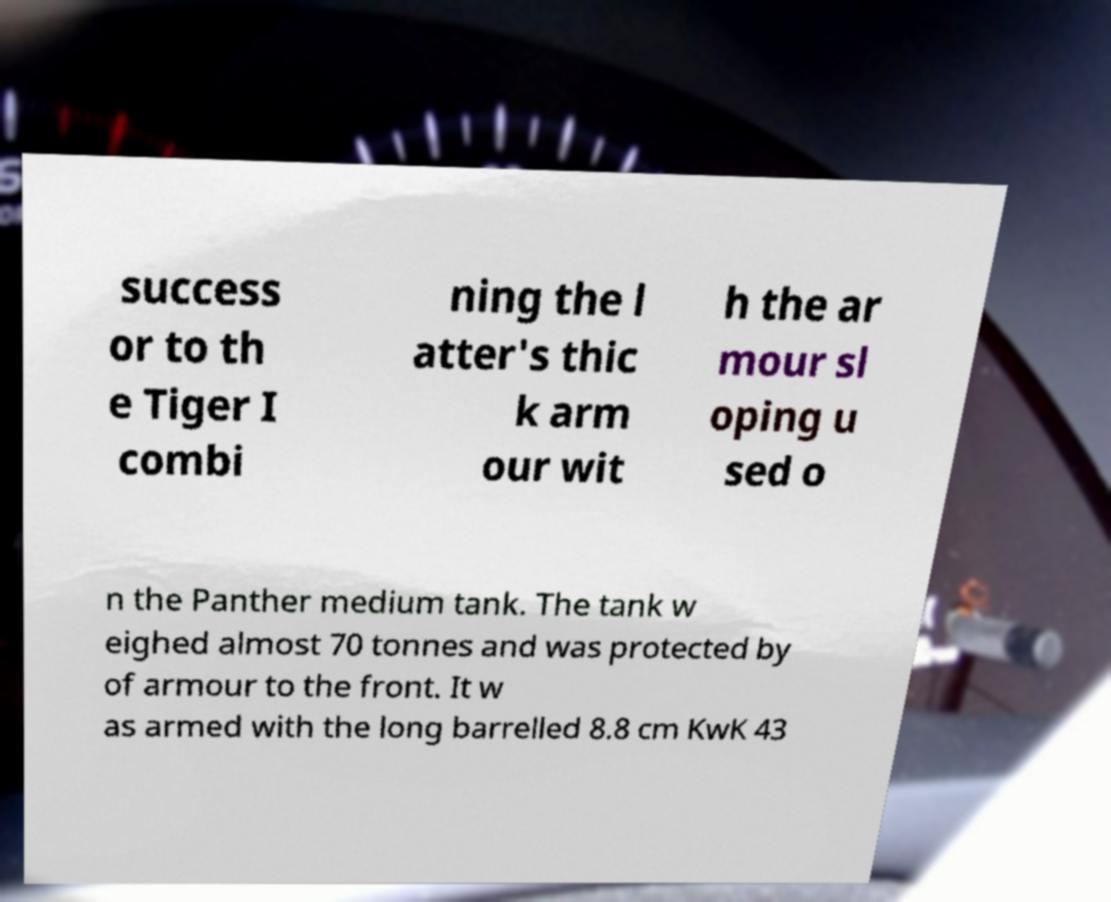Could you extract and type out the text from this image? success or to th e Tiger I combi ning the l atter's thic k arm our wit h the ar mour sl oping u sed o n the Panther medium tank. The tank w eighed almost 70 tonnes and was protected by of armour to the front. It w as armed with the long barrelled 8.8 cm KwK 43 